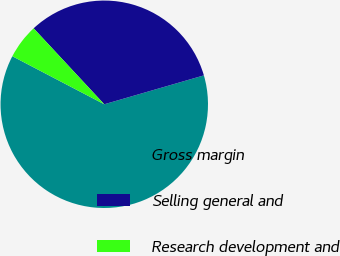Convert chart to OTSL. <chart><loc_0><loc_0><loc_500><loc_500><pie_chart><fcel>Gross margin<fcel>Selling general and<fcel>Research development and<nl><fcel>62.16%<fcel>32.43%<fcel>5.41%<nl></chart> 